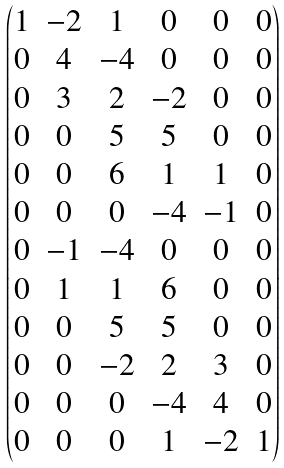<formula> <loc_0><loc_0><loc_500><loc_500>\begin{pmatrix} 1 & - 2 & 1 & 0 & 0 & 0 \\ 0 & 4 & - 4 & 0 & 0 & 0 \\ 0 & 3 & 2 & - 2 & 0 & 0 \\ 0 & 0 & 5 & 5 & 0 & 0 \\ 0 & 0 & 6 & 1 & 1 & 0 \\ 0 & 0 & 0 & - 4 & - 1 & 0 \\ 0 & - 1 & - 4 & 0 & 0 & 0 \\ 0 & 1 & 1 & 6 & 0 & 0 \\ 0 & 0 & 5 & 5 & 0 & 0 \\ 0 & 0 & - 2 & 2 & 3 & 0 \\ 0 & 0 & 0 & - 4 & 4 & 0 \\ 0 & 0 & 0 & 1 & - 2 & 1 \\ \end{pmatrix}</formula> 